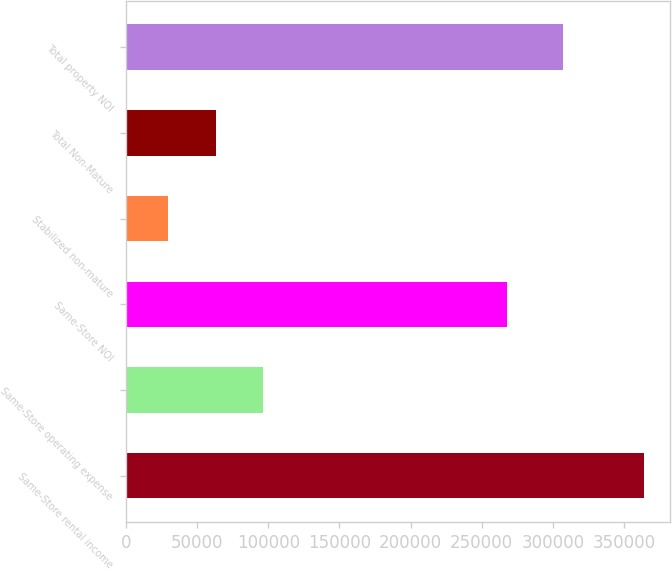Convert chart. <chart><loc_0><loc_0><loc_500><loc_500><bar_chart><fcel>Same-Store rental income<fcel>Same-Store operating expense<fcel>Same-Store NOI<fcel>Stabilized non-mature<fcel>Total Non-Mature<fcel>Total property NOI<nl><fcel>364158<fcel>96589<fcel>267569<fcel>29566<fcel>63025.2<fcel>306841<nl></chart> 